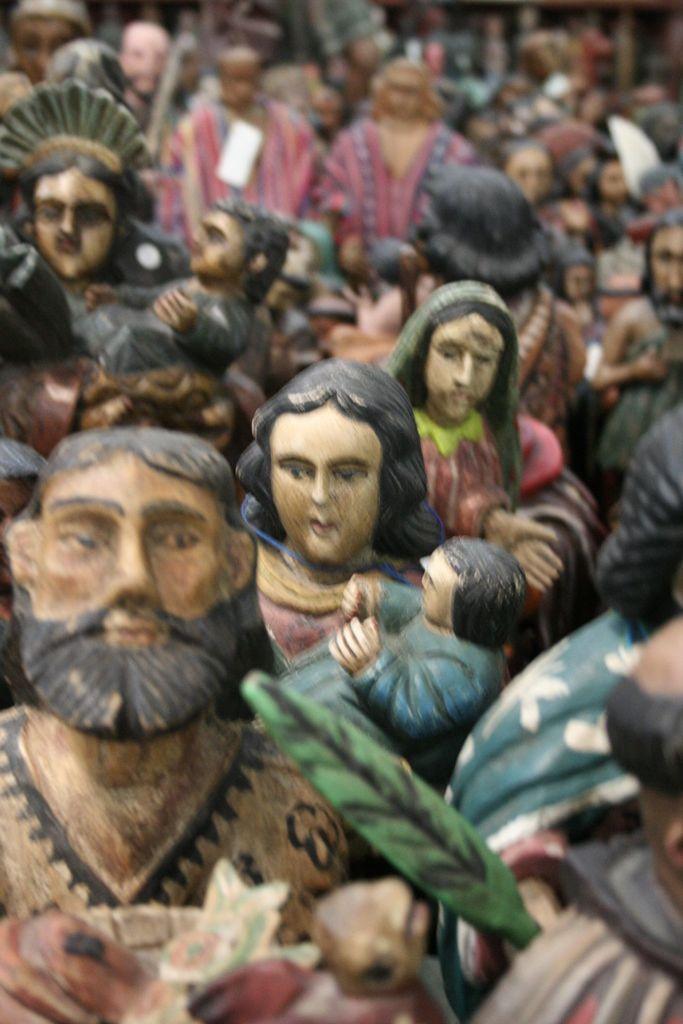Describe this image in one or two sentences. In this image I can see toys. 